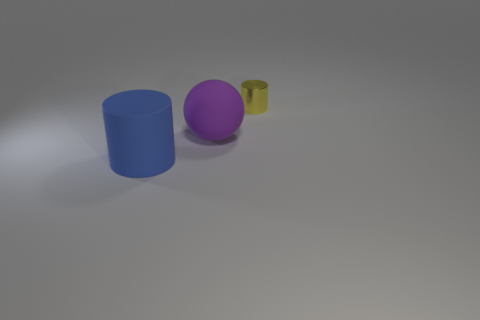Add 3 cylinders. How many objects exist? 6 Subtract all cylinders. How many objects are left? 1 Subtract all big matte spheres. Subtract all spheres. How many objects are left? 1 Add 1 yellow metallic cylinders. How many yellow metallic cylinders are left? 2 Add 3 big blue rubber things. How many big blue rubber things exist? 4 Subtract 0 gray balls. How many objects are left? 3 